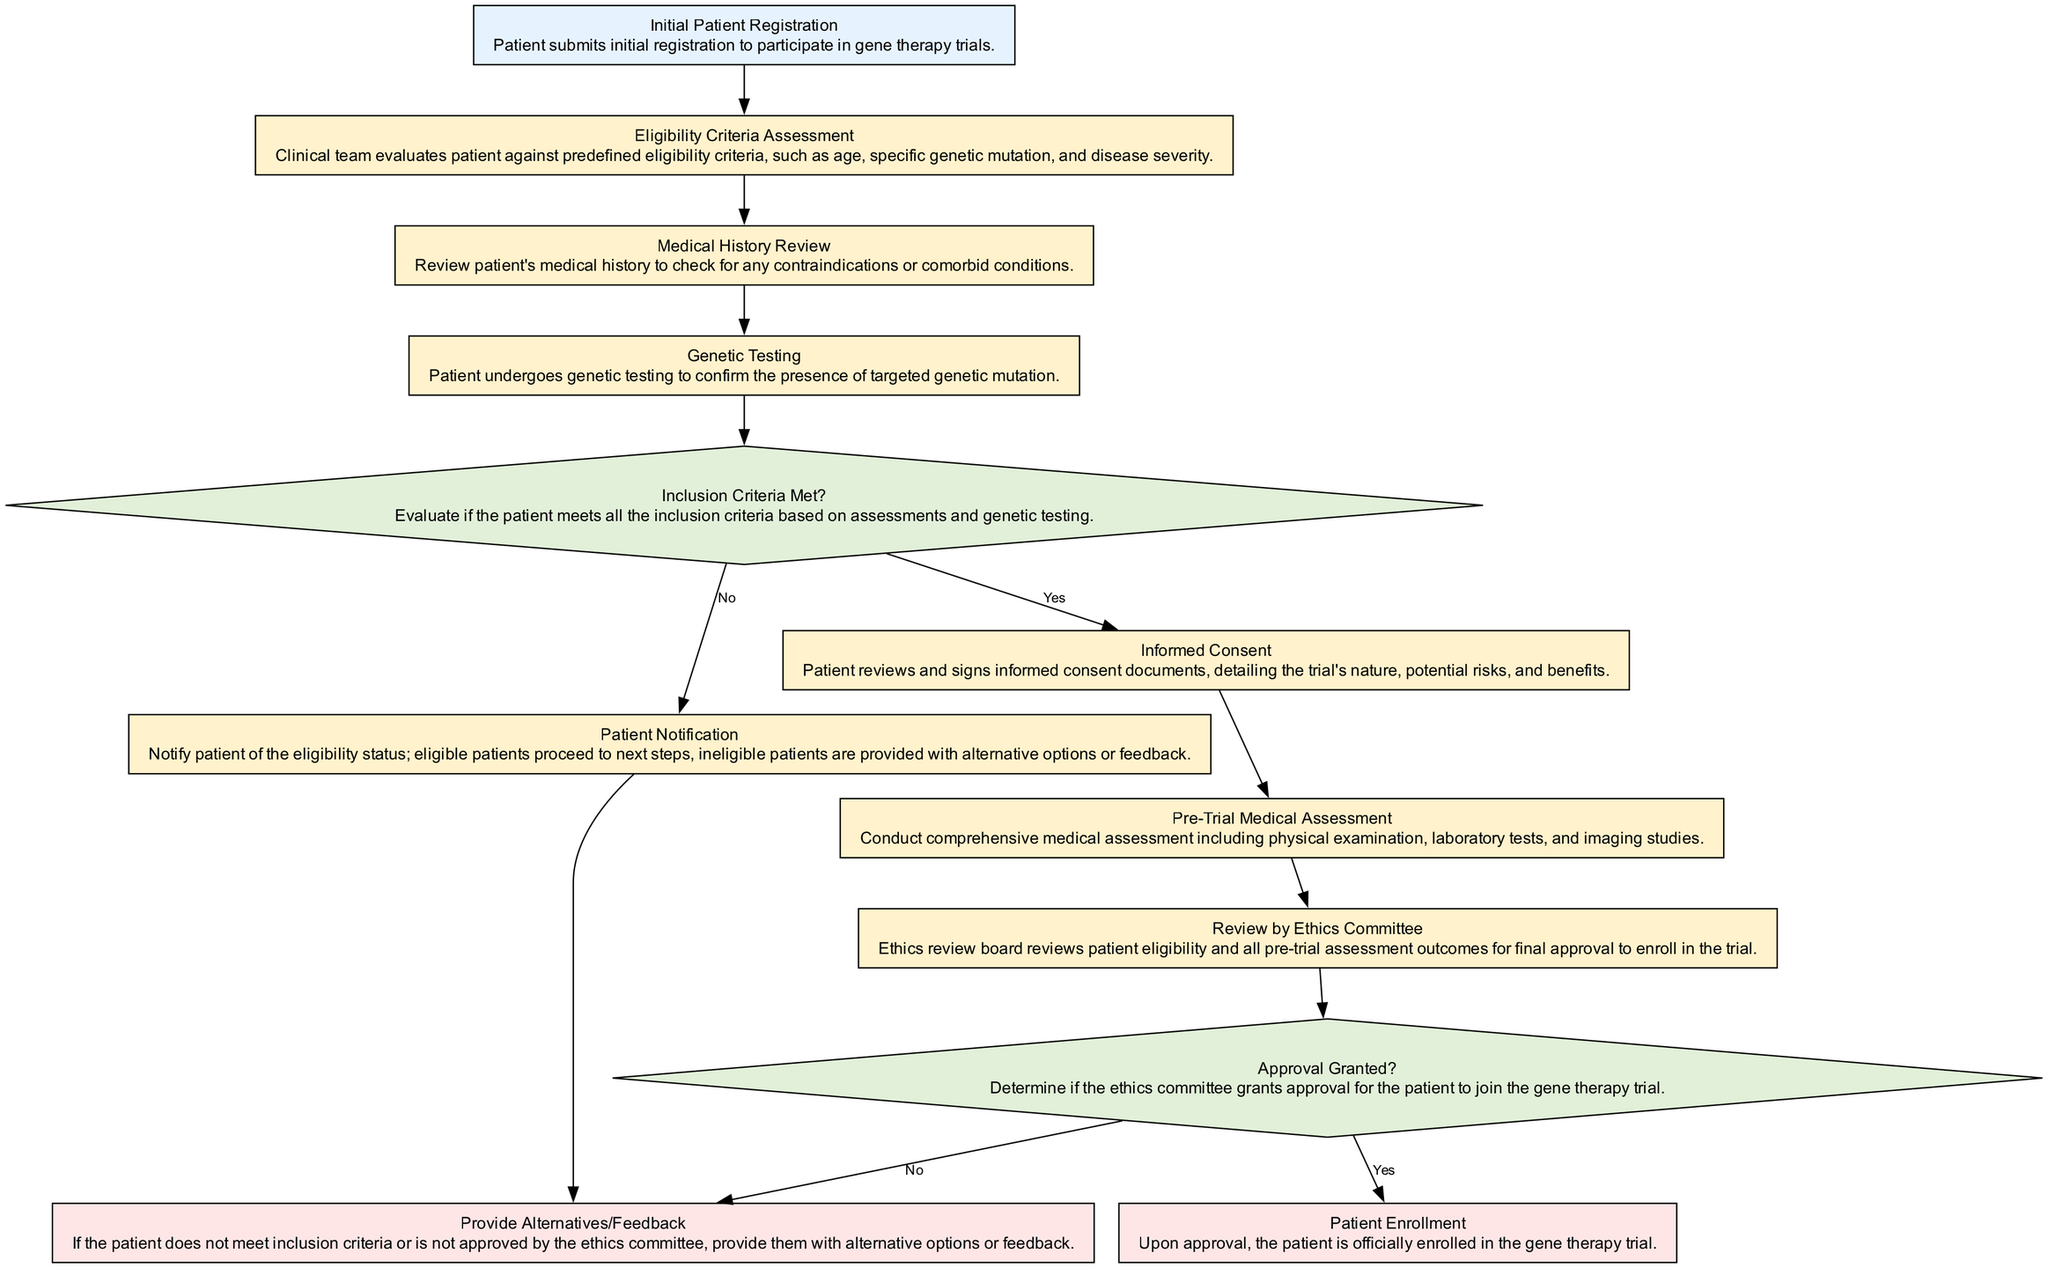What is the starting point of the diagram? The starting point of the diagram is labeled as "Initial Patient Registration," which indicates the beginning of the patient screening process.
Answer: Initial Patient Registration How many decision nodes are present in the diagram? The diagram contains two decision nodes, namely "Inclusion Criteria Met?" and "Approval Granted?" which are represented by diamond shapes.
Answer: 2 What step follows the "Genetic Testing" process? After "Genetic Testing," the next step is the decision node "Inclusion Criteria Met?" where the patient's eligibility is evaluated based on previous assessments.
Answer: Inclusion Criteria Met? What happens if inclusion criteria are not met? If inclusion criteria are not met, the process goes to "Patient Notification," and eventually to "Provide Alternatives/Feedback," which offers patients other options.
Answer: Provide Alternatives/Feedback What is the last step in the flowchart when the ethics committee grants approval? If the ethics committee grants approval, the final step in the flowchart is "Patient Enrollment," which marks the official enrollment of the patient in the gene therapy trial.
Answer: Patient Enrollment How many total steps are involved in the patient screening process? The total steps involved include all process nodes and decision nodes, totaling 12 unique elements including start and end points.
Answer: 12 